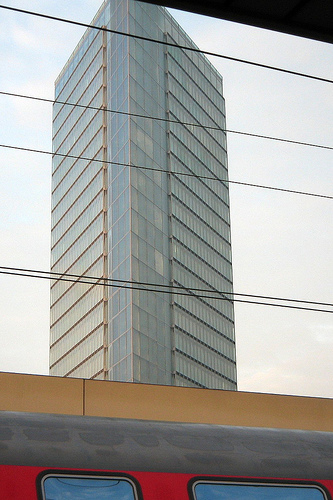<image>
Is the wires in front of the building? Yes. The wires is positioned in front of the building, appearing closer to the camera viewpoint. 